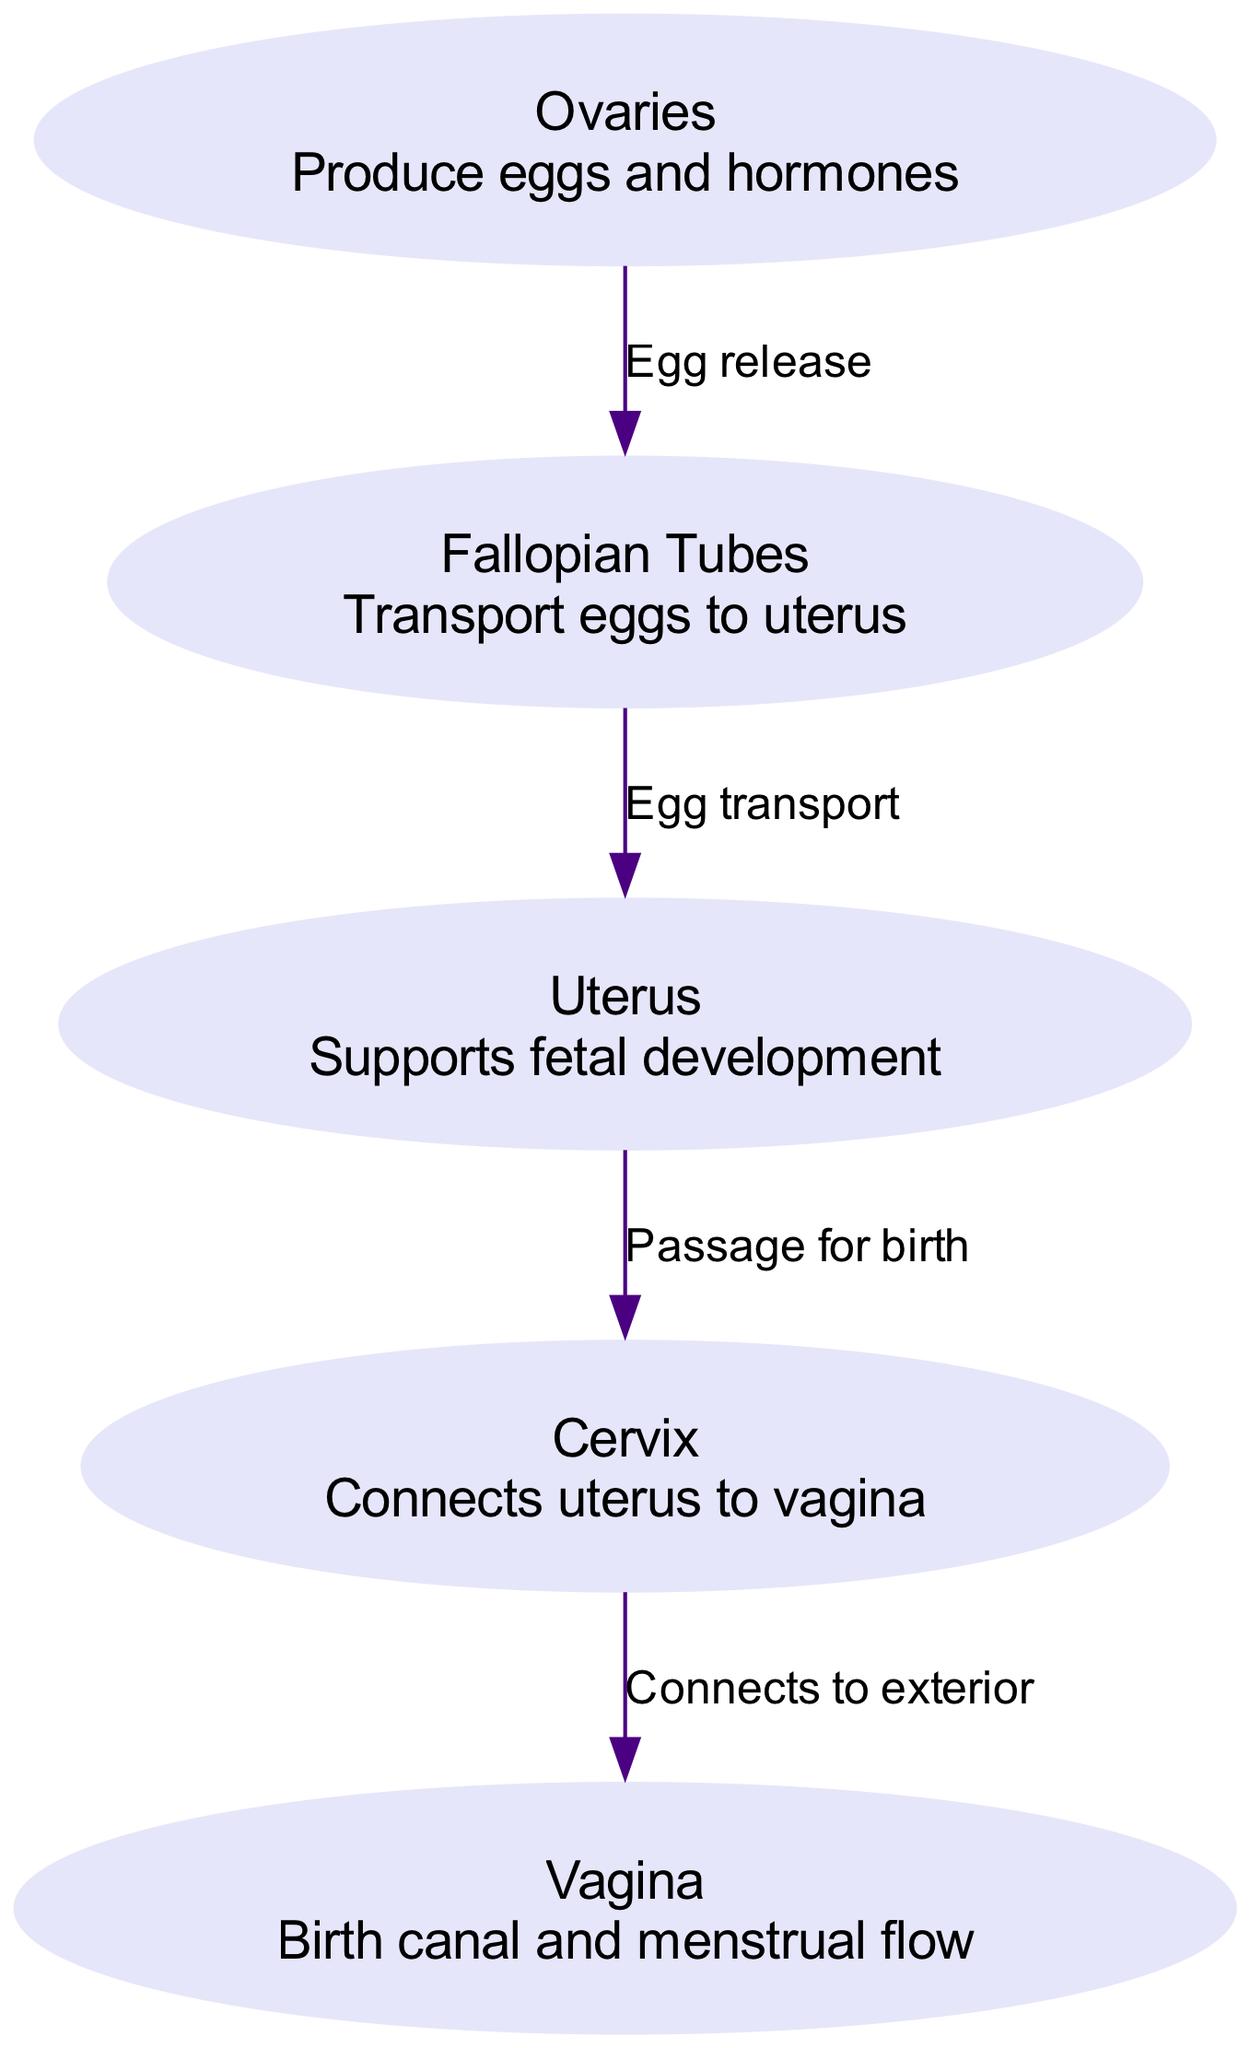What is the function of the ovaries? The ovaries are described in the diagram as organs that produce eggs and hormones. Therefore, their primary function is to facilitate reproduction and hormone regulation.
Answer: Produce eggs and hormones How many organs are labeled in the diagram? By counting the labeled nodes in the diagram, we see there are five distinct organs highlighted: ovaries, fallopian tubes, uterus, cervix, and vagina. This leads to a total of five organs.
Answer: 5 What connects the uterus to the vagina? The diagram indicates that the cervix connects the uterus to the vagina. The description associated with the cervix in the diagram confirms this relationship.
Answer: Cervix What is transported from the fallopian tubes to the uterus? The labeled edge in the diagram specifies that eggs are transported from the fallopian tubes to the uterus. The edge label explicitly states 'Egg transport.'
Answer: Eggs Which organ supports fetal development? The diagram specifically states that the uterus is responsible for supporting fetal development. This is directly written in the description associated with the uterus node.
Answer: Uterus What is the pathway for birth as indicated in the diagram? The diagram shows that the pathway for birth goes from the uterus to the cervix and then to the vagina. By following the labeled edges, this process can be traced clearly.
Answer: Uterus to cervix to vagina What does the vagina serve as, according to the diagram? The diagram indicates that the vagina acts as a birth canal and facilitates menstrual flow. This description clearly defines the multiple roles of the vagina.
Answer: Birth canal and menstrual flow Which organ's function involves egg release? According to the diagram, the ovaries have the function of egg release. The edge from the ovaries states 'Egg release,' which clearly identifies this function.
Answer: Ovaries 